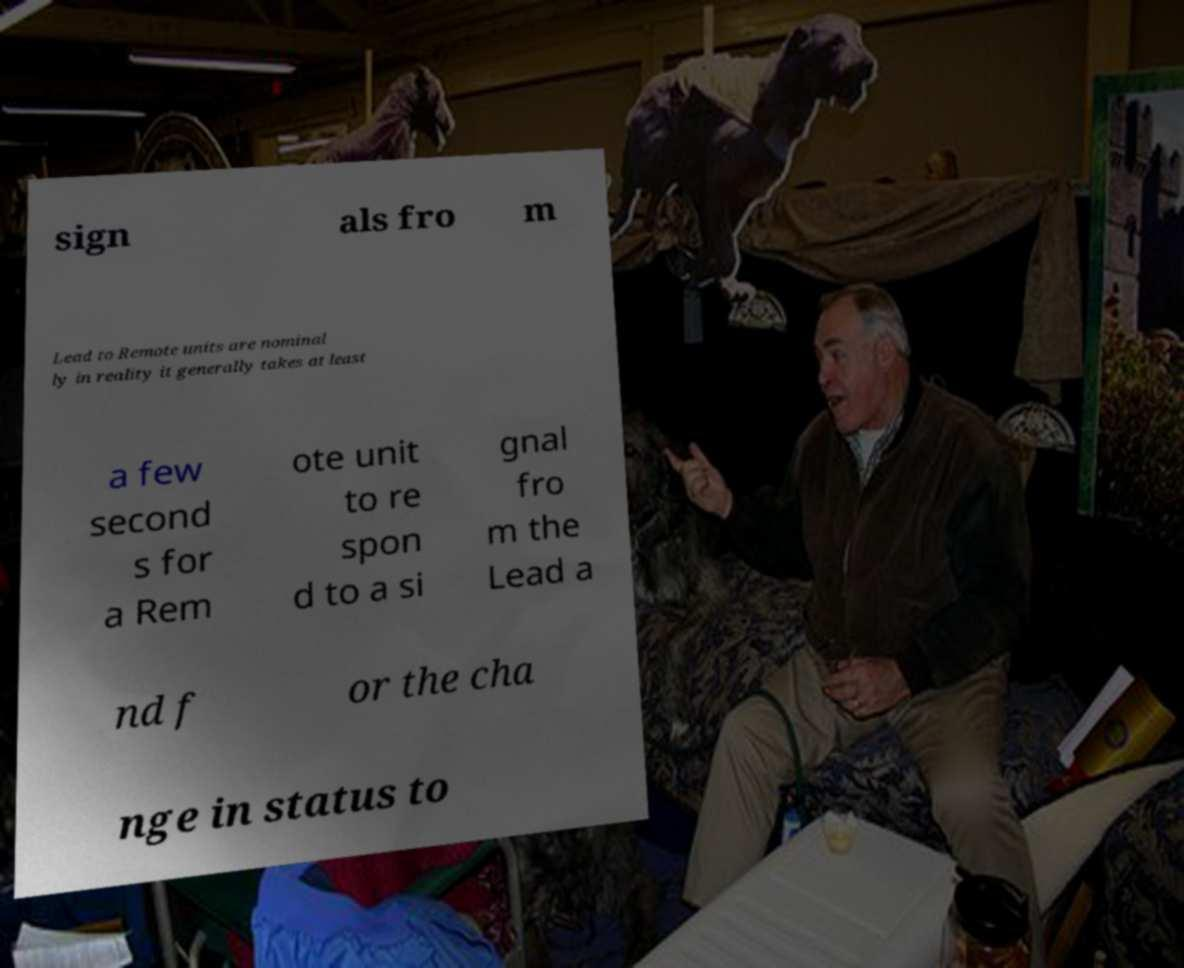Please identify and transcribe the text found in this image. sign als fro m Lead to Remote units are nominal ly in reality it generally takes at least a few second s for a Rem ote unit to re spon d to a si gnal fro m the Lead a nd f or the cha nge in status to 